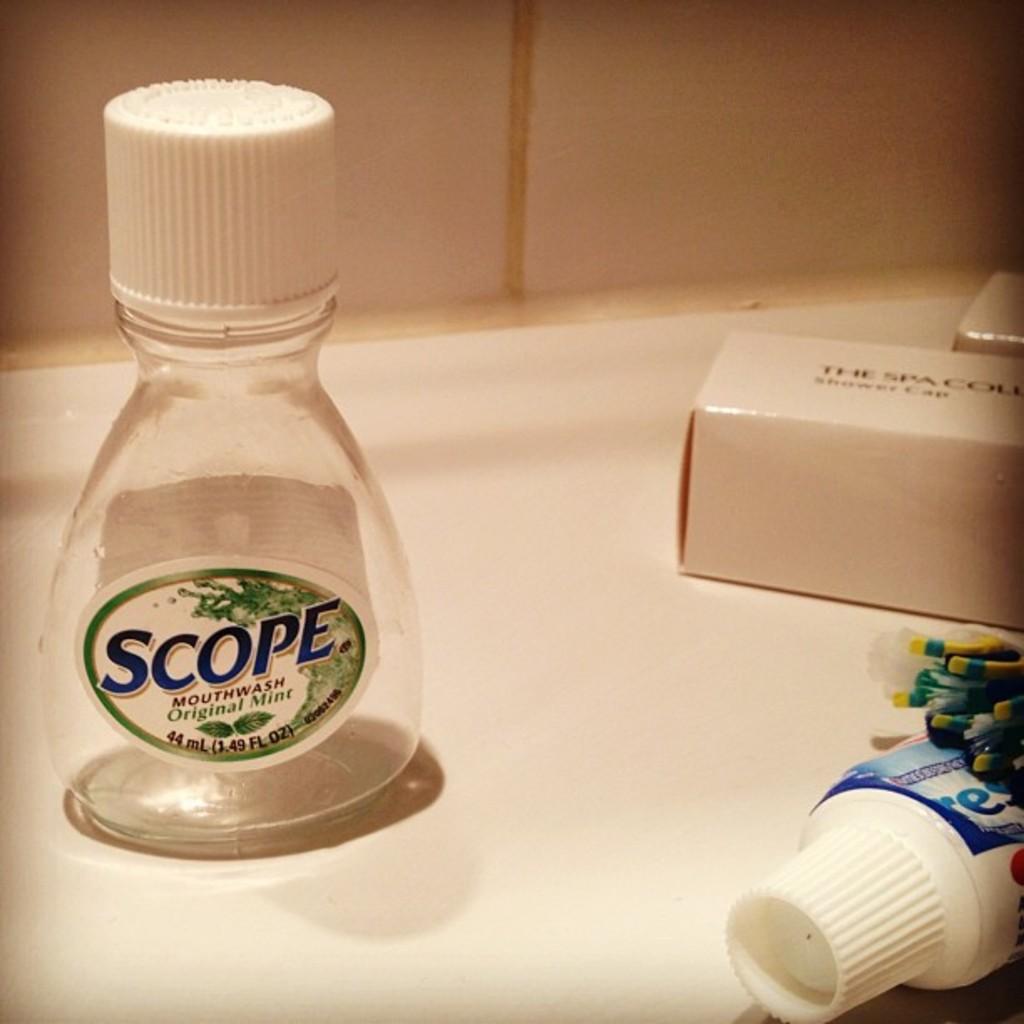What brand mouthwash is that?
Ensure brevity in your answer.  Scope. What mouthwash brand is that?
Provide a succinct answer. Scope. 